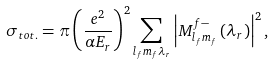Convert formula to latex. <formula><loc_0><loc_0><loc_500><loc_500>\sigma _ { t o t . } = \pi \left ( \frac { e ^ { 2 } } { \alpha E _ { r } } \right ) ^ { 2 } \sum _ { l _ { f } m _ { f } \lambda _ { r } } \left | M _ { l _ { f } m _ { f } } ^ { f - } \left ( \lambda _ { r } \right ) \right | ^ { 2 } ,</formula> 